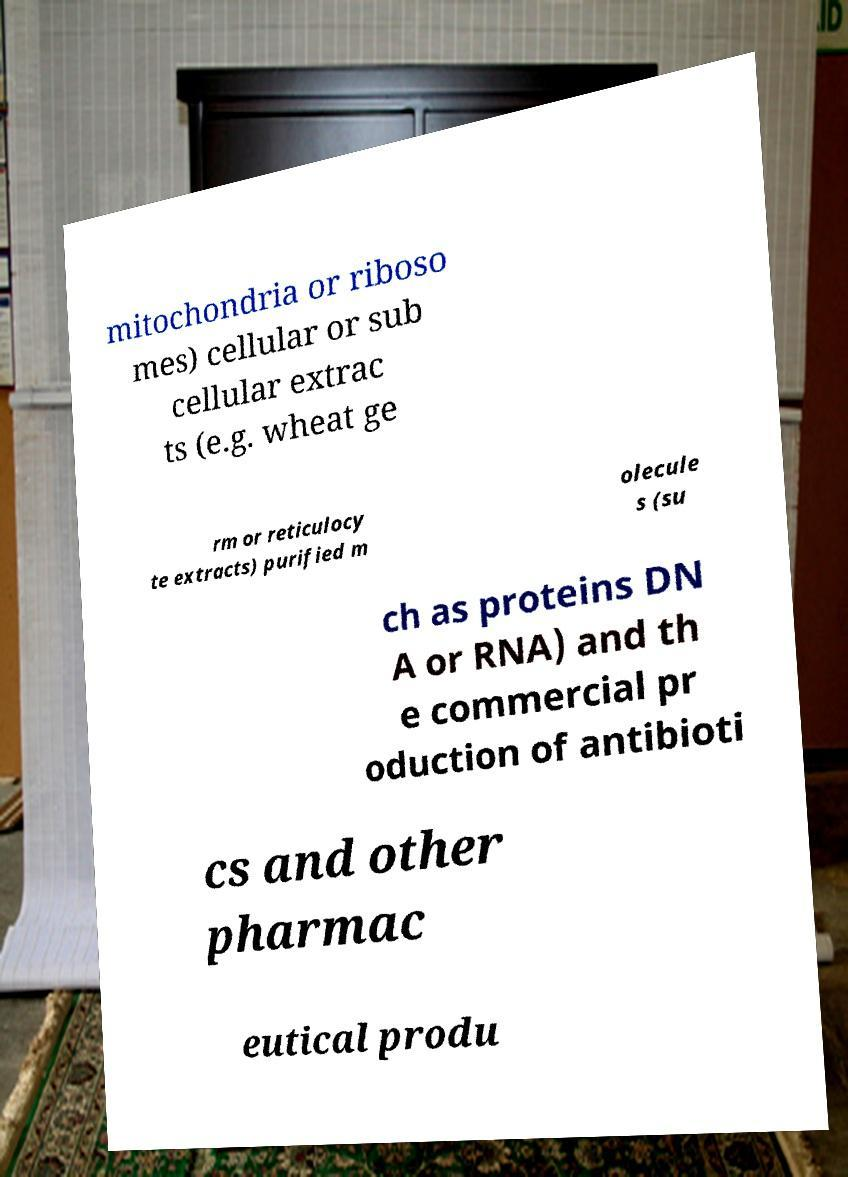Please identify and transcribe the text found in this image. mitochondria or riboso mes) cellular or sub cellular extrac ts (e.g. wheat ge rm or reticulocy te extracts) purified m olecule s (su ch as proteins DN A or RNA) and th e commercial pr oduction of antibioti cs and other pharmac eutical produ 